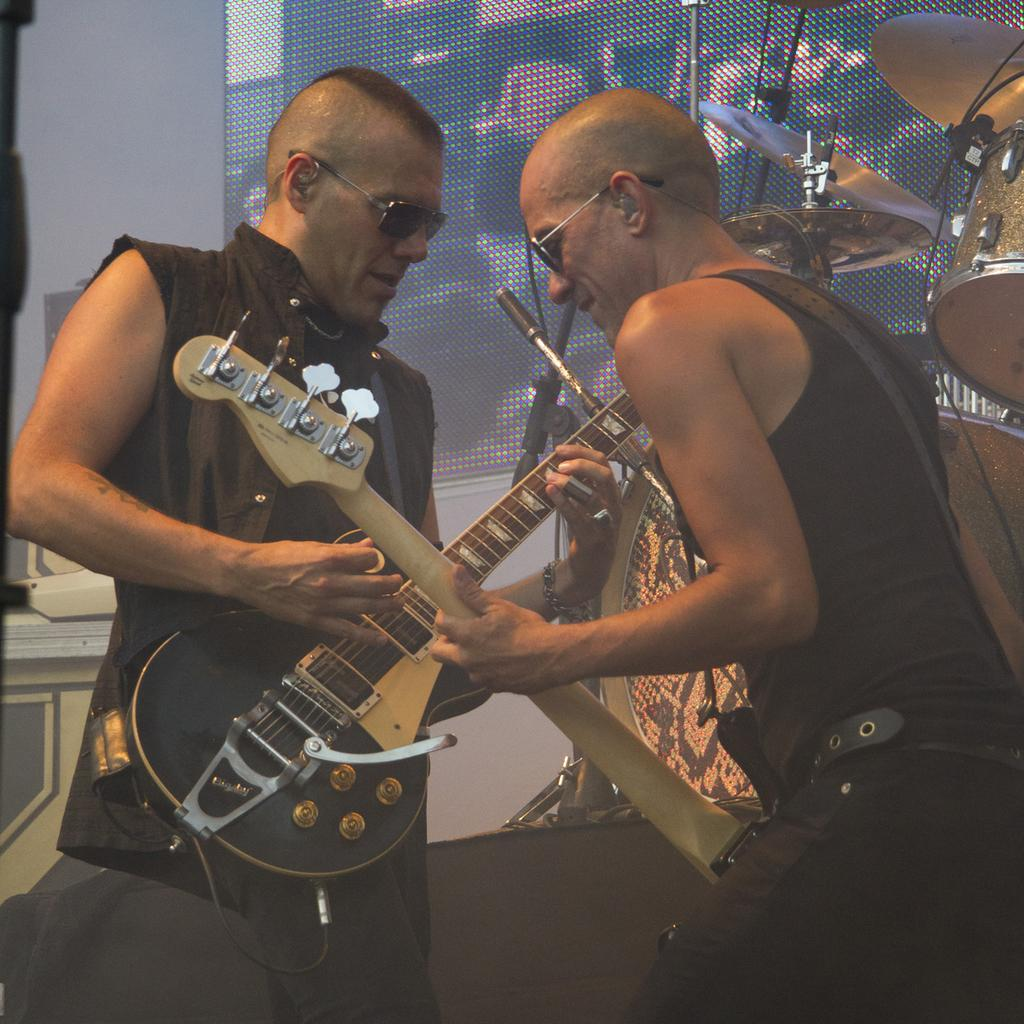How many people are in the image? There are two men in the image. What are the men holding in the image? Both men are holding guitars. Can you describe the reflection visible in the image? One person's reflection is visible in the image. What other musical instruments can be seen in the image? There are drums in the image. What type of object is present that might be used for displaying information or visuals? There is a screen in the image. What type of corn is being grown in the image? There is no corn present in the image. How does the society depicted in the image function? The image does not depict a society, so it cannot be determined how it functions. 